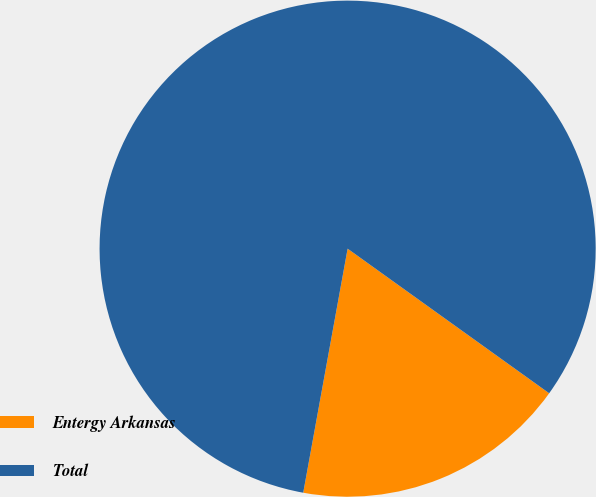Convert chart to OTSL. <chart><loc_0><loc_0><loc_500><loc_500><pie_chart><fcel>Entergy Arkansas<fcel>Total<nl><fcel>17.96%<fcel>82.04%<nl></chart> 